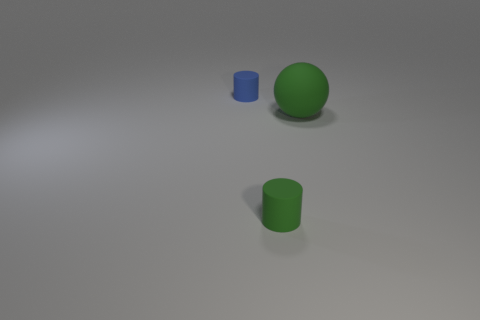There is a small object in front of the thing that is left of the small cylinder right of the tiny blue cylinder; what shape is it?
Your answer should be compact. Cylinder. How many tiny blue things have the same material as the green ball?
Offer a terse response. 1. There is a tiny thing on the right side of the small blue cylinder; what number of green matte objects are behind it?
Provide a succinct answer. 1. Do the small cylinder that is in front of the blue cylinder and the large rubber sphere to the right of the blue matte object have the same color?
Keep it short and to the point. Yes. There is a thing that is behind the green cylinder and to the left of the green sphere; what shape is it?
Make the answer very short. Cylinder. Is there a large brown shiny object of the same shape as the big rubber object?
Provide a short and direct response. No. What is the shape of the other thing that is the same size as the blue rubber object?
Provide a short and direct response. Cylinder. What is the material of the blue object?
Your answer should be very brief. Rubber. What size is the green rubber thing behind the tiny cylinder in front of the object on the left side of the small green cylinder?
Offer a very short reply. Large. There is a tiny object that is the same color as the large sphere; what is its material?
Your response must be concise. Rubber. 